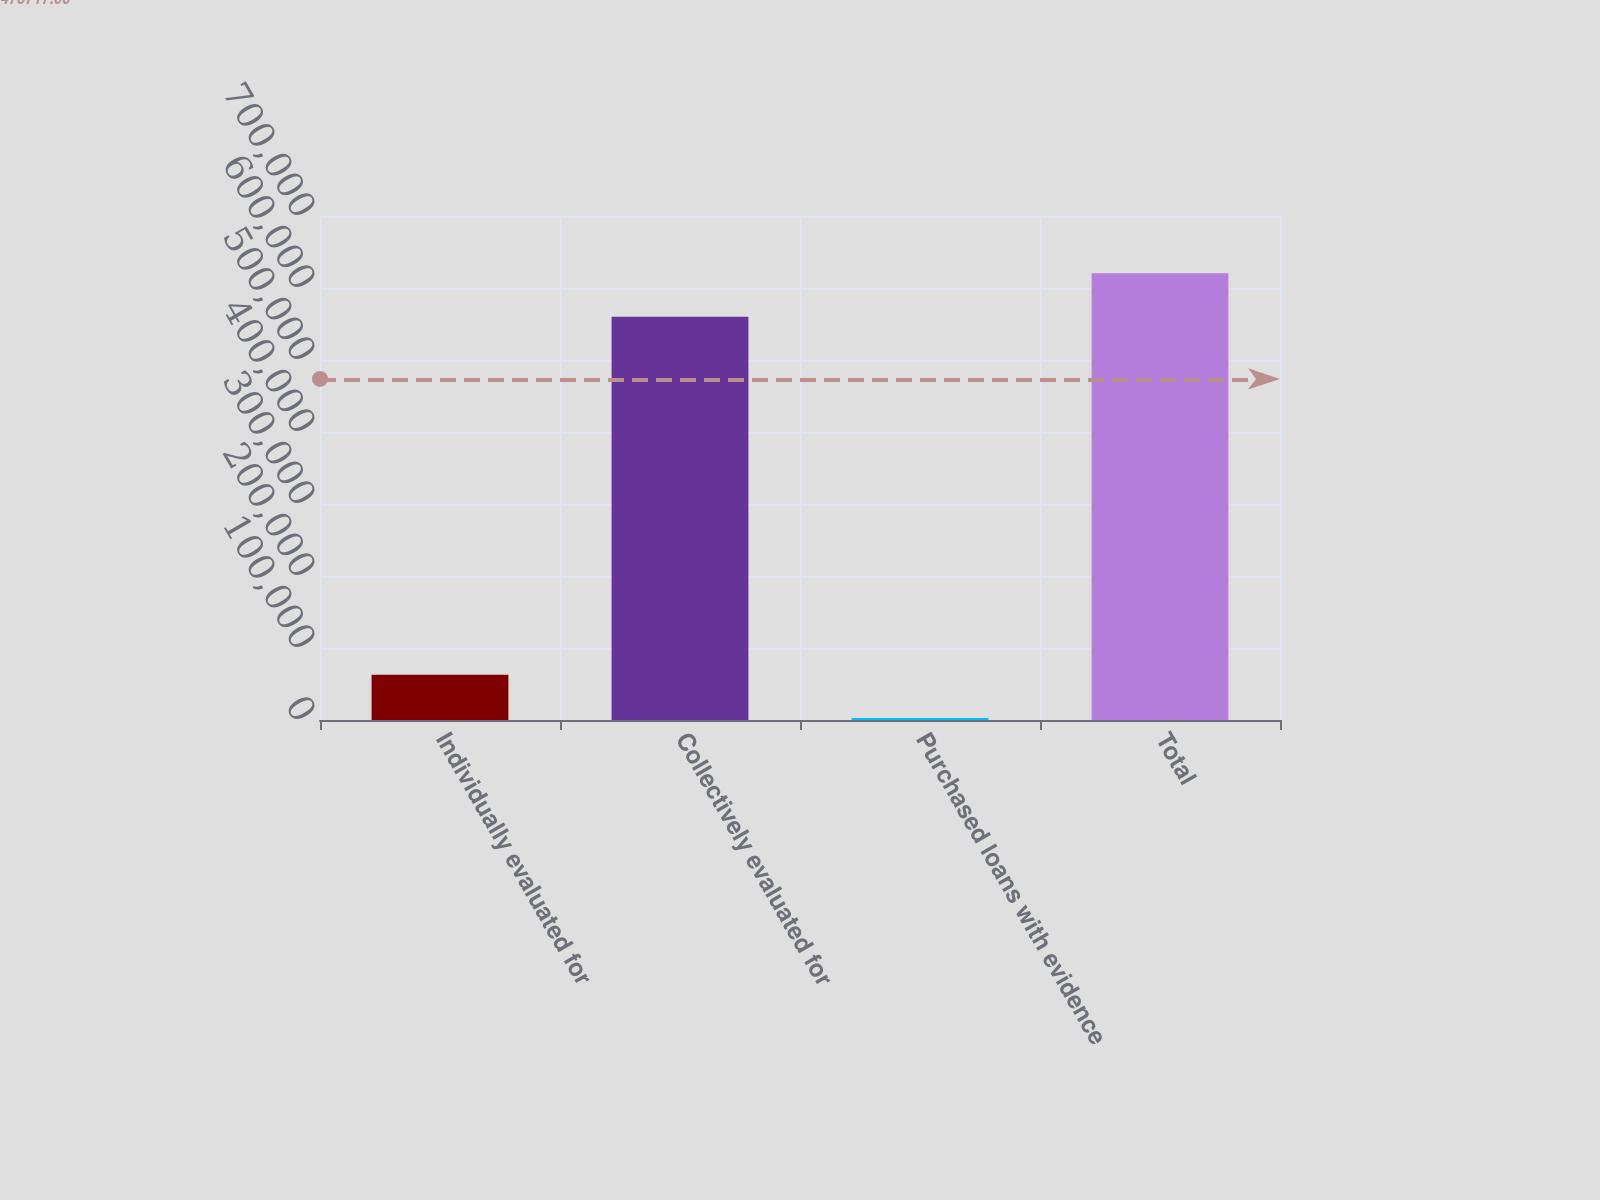Convert chart. <chart><loc_0><loc_0><loc_500><loc_500><bar_chart><fcel>Individually evaluated for<fcel>Collectively evaluated for<fcel>Purchased loans with evidence<fcel>Total<nl><fcel>62986.3<fcel>560150<fcel>2800<fcel>620336<nl></chart> 